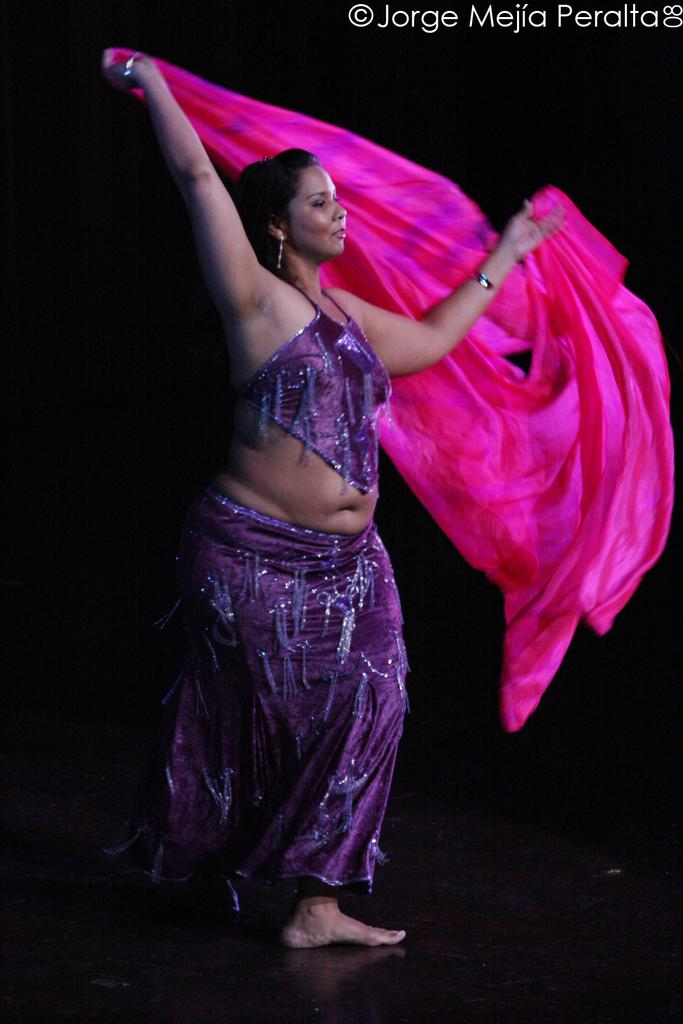Who is the main subject in the image? There is a lady in the image. What is the lady wearing? The lady is wearing a violet dress. What is the lady holding in her hands? The lady is holding a pink cloth in her hands. Can you describe any text or labels in the image? There is a name in the top right corner of the image. How many pies are being baked during the rainstorm in the image? There is no mention of pies or a rainstorm in the image. 